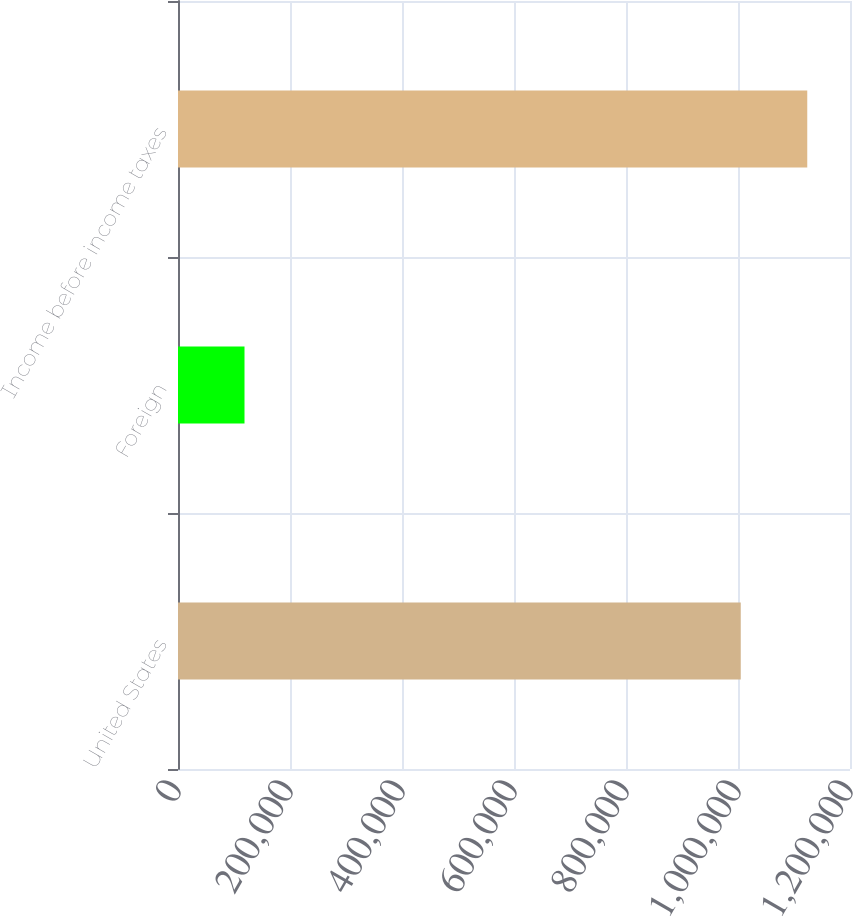<chart> <loc_0><loc_0><loc_500><loc_500><bar_chart><fcel>United States<fcel>Foreign<fcel>Income before income taxes<nl><fcel>1.00492e+06<fcel>118762<fcel>1.12368e+06<nl></chart> 